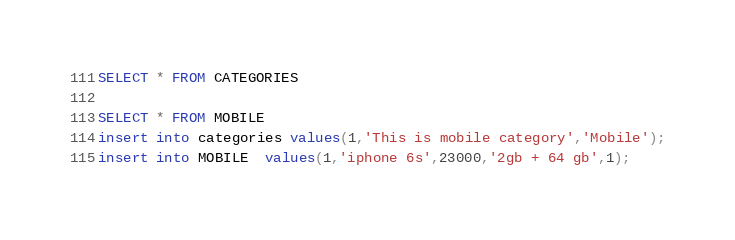<code> <loc_0><loc_0><loc_500><loc_500><_SQL_>SELECT * FROM CATEGORIES 

SELECT * FROM MOBILE 
insert into categories values(1,'This is mobile category','Mobile');
insert into MOBILE  values(1,'iphone 6s',23000,'2gb + 64 gb',1);</code> 